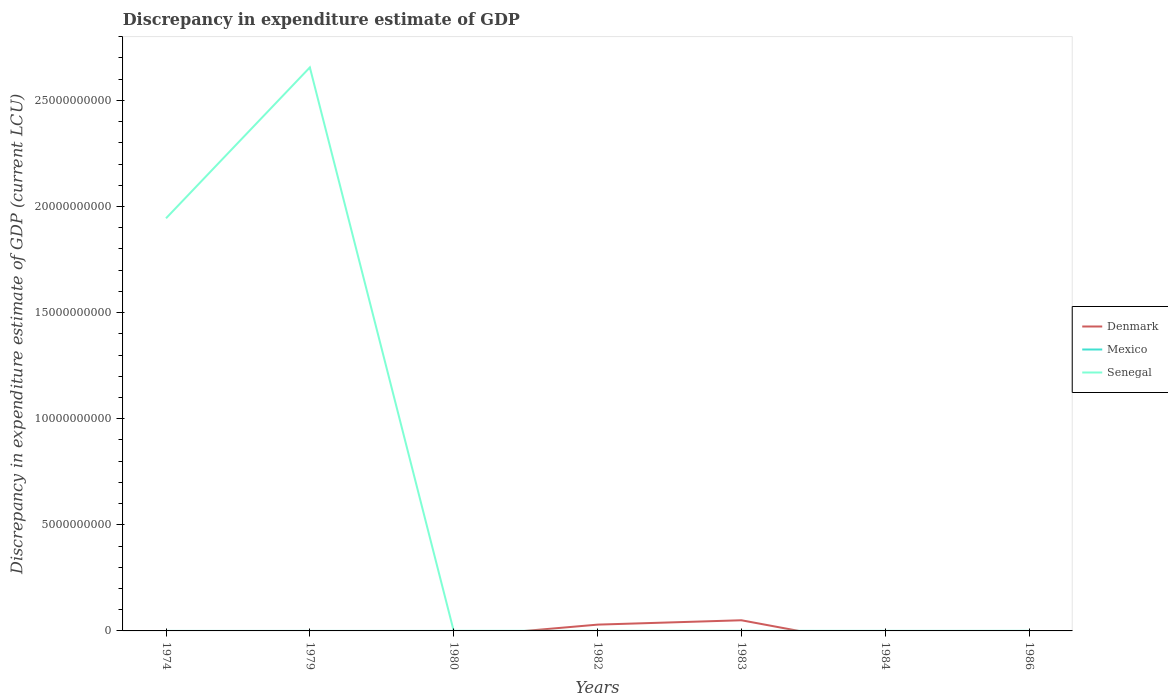How many different coloured lines are there?
Your answer should be compact. 3. Does the line corresponding to Denmark intersect with the line corresponding to Mexico?
Your answer should be very brief. Yes. What is the total discrepancy in expenditure estimate of GDP in Senegal in the graph?
Your answer should be compact. -100. What is the difference between the highest and the second highest discrepancy in expenditure estimate of GDP in Denmark?
Your answer should be very brief. 5.02e+08. Is the discrepancy in expenditure estimate of GDP in Mexico strictly greater than the discrepancy in expenditure estimate of GDP in Senegal over the years?
Keep it short and to the point. No. How many lines are there?
Your answer should be very brief. 3. What is the difference between two consecutive major ticks on the Y-axis?
Provide a succinct answer. 5.00e+09. Does the graph contain any zero values?
Offer a terse response. Yes. Does the graph contain grids?
Make the answer very short. No. How are the legend labels stacked?
Your answer should be very brief. Vertical. What is the title of the graph?
Provide a succinct answer. Discrepancy in expenditure estimate of GDP. What is the label or title of the Y-axis?
Provide a succinct answer. Discrepancy in expenditure estimate of GDP (current LCU). What is the Discrepancy in expenditure estimate of GDP (current LCU) of Denmark in 1974?
Your response must be concise. 0. What is the Discrepancy in expenditure estimate of GDP (current LCU) in Mexico in 1974?
Provide a short and direct response. 1.80e+04. What is the Discrepancy in expenditure estimate of GDP (current LCU) of Senegal in 1974?
Provide a succinct answer. 1.94e+1. What is the Discrepancy in expenditure estimate of GDP (current LCU) in Denmark in 1979?
Your response must be concise. 0. What is the Discrepancy in expenditure estimate of GDP (current LCU) in Mexico in 1979?
Provide a short and direct response. 0. What is the Discrepancy in expenditure estimate of GDP (current LCU) of Senegal in 1979?
Ensure brevity in your answer.  2.66e+1. What is the Discrepancy in expenditure estimate of GDP (current LCU) of Senegal in 1980?
Your answer should be very brief. 6e-5. What is the Discrepancy in expenditure estimate of GDP (current LCU) in Denmark in 1982?
Your answer should be compact. 2.96e+08. What is the Discrepancy in expenditure estimate of GDP (current LCU) in Senegal in 1982?
Offer a very short reply. 0. What is the Discrepancy in expenditure estimate of GDP (current LCU) in Denmark in 1983?
Give a very brief answer. 5.02e+08. What is the Discrepancy in expenditure estimate of GDP (current LCU) in Mexico in 1983?
Your response must be concise. 4.65e+05. What is the Discrepancy in expenditure estimate of GDP (current LCU) in Senegal in 1983?
Give a very brief answer. 0. What is the Discrepancy in expenditure estimate of GDP (current LCU) in Denmark in 1984?
Give a very brief answer. 0. What is the Discrepancy in expenditure estimate of GDP (current LCU) in Senegal in 1984?
Your response must be concise. 100. What is the Discrepancy in expenditure estimate of GDP (current LCU) of Mexico in 1986?
Provide a succinct answer. 9.40e+04. Across all years, what is the maximum Discrepancy in expenditure estimate of GDP (current LCU) of Denmark?
Provide a succinct answer. 5.02e+08. Across all years, what is the maximum Discrepancy in expenditure estimate of GDP (current LCU) in Mexico?
Make the answer very short. 4.65e+05. Across all years, what is the maximum Discrepancy in expenditure estimate of GDP (current LCU) in Senegal?
Make the answer very short. 2.66e+1. Across all years, what is the minimum Discrepancy in expenditure estimate of GDP (current LCU) of Denmark?
Your answer should be compact. 0. What is the total Discrepancy in expenditure estimate of GDP (current LCU) of Denmark in the graph?
Give a very brief answer. 7.99e+08. What is the total Discrepancy in expenditure estimate of GDP (current LCU) of Mexico in the graph?
Give a very brief answer. 7.07e+05. What is the total Discrepancy in expenditure estimate of GDP (current LCU) of Senegal in the graph?
Ensure brevity in your answer.  4.60e+1. What is the difference between the Discrepancy in expenditure estimate of GDP (current LCU) of Senegal in 1974 and that in 1979?
Your response must be concise. -7.11e+09. What is the difference between the Discrepancy in expenditure estimate of GDP (current LCU) in Mexico in 1974 and that in 1980?
Provide a short and direct response. -1.12e+05. What is the difference between the Discrepancy in expenditure estimate of GDP (current LCU) in Senegal in 1974 and that in 1980?
Provide a succinct answer. 1.94e+1. What is the difference between the Discrepancy in expenditure estimate of GDP (current LCU) in Senegal in 1974 and that in 1982?
Your answer should be very brief. 1.94e+1. What is the difference between the Discrepancy in expenditure estimate of GDP (current LCU) in Mexico in 1974 and that in 1983?
Your answer should be compact. -4.47e+05. What is the difference between the Discrepancy in expenditure estimate of GDP (current LCU) in Senegal in 1974 and that in 1983?
Offer a very short reply. 1.94e+1. What is the difference between the Discrepancy in expenditure estimate of GDP (current LCU) in Senegal in 1974 and that in 1984?
Your answer should be very brief. 1.94e+1. What is the difference between the Discrepancy in expenditure estimate of GDP (current LCU) in Mexico in 1974 and that in 1986?
Give a very brief answer. -7.60e+04. What is the difference between the Discrepancy in expenditure estimate of GDP (current LCU) in Senegal in 1979 and that in 1980?
Make the answer very short. 2.66e+1. What is the difference between the Discrepancy in expenditure estimate of GDP (current LCU) in Senegal in 1979 and that in 1982?
Your response must be concise. 2.66e+1. What is the difference between the Discrepancy in expenditure estimate of GDP (current LCU) of Senegal in 1979 and that in 1983?
Ensure brevity in your answer.  2.66e+1. What is the difference between the Discrepancy in expenditure estimate of GDP (current LCU) of Senegal in 1979 and that in 1984?
Your answer should be compact. 2.66e+1. What is the difference between the Discrepancy in expenditure estimate of GDP (current LCU) in Senegal in 1980 and that in 1982?
Ensure brevity in your answer.  -0. What is the difference between the Discrepancy in expenditure estimate of GDP (current LCU) in Mexico in 1980 and that in 1983?
Provide a short and direct response. -3.35e+05. What is the difference between the Discrepancy in expenditure estimate of GDP (current LCU) of Senegal in 1980 and that in 1983?
Provide a succinct answer. -0. What is the difference between the Discrepancy in expenditure estimate of GDP (current LCU) of Senegal in 1980 and that in 1984?
Make the answer very short. -100. What is the difference between the Discrepancy in expenditure estimate of GDP (current LCU) in Mexico in 1980 and that in 1986?
Offer a terse response. 3.60e+04. What is the difference between the Discrepancy in expenditure estimate of GDP (current LCU) of Denmark in 1982 and that in 1983?
Your response must be concise. -2.06e+08. What is the difference between the Discrepancy in expenditure estimate of GDP (current LCU) in Senegal in 1982 and that in 1983?
Ensure brevity in your answer.  -0. What is the difference between the Discrepancy in expenditure estimate of GDP (current LCU) of Senegal in 1982 and that in 1984?
Provide a succinct answer. -100. What is the difference between the Discrepancy in expenditure estimate of GDP (current LCU) of Senegal in 1983 and that in 1984?
Keep it short and to the point. -100. What is the difference between the Discrepancy in expenditure estimate of GDP (current LCU) of Mexico in 1983 and that in 1986?
Provide a short and direct response. 3.71e+05. What is the difference between the Discrepancy in expenditure estimate of GDP (current LCU) of Mexico in 1974 and the Discrepancy in expenditure estimate of GDP (current LCU) of Senegal in 1979?
Provide a succinct answer. -2.66e+1. What is the difference between the Discrepancy in expenditure estimate of GDP (current LCU) in Mexico in 1974 and the Discrepancy in expenditure estimate of GDP (current LCU) in Senegal in 1980?
Ensure brevity in your answer.  1.80e+04. What is the difference between the Discrepancy in expenditure estimate of GDP (current LCU) in Mexico in 1974 and the Discrepancy in expenditure estimate of GDP (current LCU) in Senegal in 1982?
Keep it short and to the point. 1.80e+04. What is the difference between the Discrepancy in expenditure estimate of GDP (current LCU) in Mexico in 1974 and the Discrepancy in expenditure estimate of GDP (current LCU) in Senegal in 1983?
Offer a terse response. 1.80e+04. What is the difference between the Discrepancy in expenditure estimate of GDP (current LCU) of Mexico in 1974 and the Discrepancy in expenditure estimate of GDP (current LCU) of Senegal in 1984?
Provide a short and direct response. 1.79e+04. What is the difference between the Discrepancy in expenditure estimate of GDP (current LCU) of Mexico in 1980 and the Discrepancy in expenditure estimate of GDP (current LCU) of Senegal in 1982?
Offer a terse response. 1.30e+05. What is the difference between the Discrepancy in expenditure estimate of GDP (current LCU) in Mexico in 1980 and the Discrepancy in expenditure estimate of GDP (current LCU) in Senegal in 1983?
Provide a short and direct response. 1.30e+05. What is the difference between the Discrepancy in expenditure estimate of GDP (current LCU) of Mexico in 1980 and the Discrepancy in expenditure estimate of GDP (current LCU) of Senegal in 1984?
Provide a short and direct response. 1.30e+05. What is the difference between the Discrepancy in expenditure estimate of GDP (current LCU) in Denmark in 1982 and the Discrepancy in expenditure estimate of GDP (current LCU) in Mexico in 1983?
Keep it short and to the point. 2.96e+08. What is the difference between the Discrepancy in expenditure estimate of GDP (current LCU) in Denmark in 1982 and the Discrepancy in expenditure estimate of GDP (current LCU) in Senegal in 1983?
Make the answer very short. 2.96e+08. What is the difference between the Discrepancy in expenditure estimate of GDP (current LCU) of Denmark in 1982 and the Discrepancy in expenditure estimate of GDP (current LCU) of Senegal in 1984?
Keep it short and to the point. 2.96e+08. What is the difference between the Discrepancy in expenditure estimate of GDP (current LCU) in Denmark in 1982 and the Discrepancy in expenditure estimate of GDP (current LCU) in Mexico in 1986?
Offer a terse response. 2.96e+08. What is the difference between the Discrepancy in expenditure estimate of GDP (current LCU) in Denmark in 1983 and the Discrepancy in expenditure estimate of GDP (current LCU) in Senegal in 1984?
Offer a terse response. 5.02e+08. What is the difference between the Discrepancy in expenditure estimate of GDP (current LCU) of Mexico in 1983 and the Discrepancy in expenditure estimate of GDP (current LCU) of Senegal in 1984?
Provide a short and direct response. 4.65e+05. What is the difference between the Discrepancy in expenditure estimate of GDP (current LCU) of Denmark in 1983 and the Discrepancy in expenditure estimate of GDP (current LCU) of Mexico in 1986?
Ensure brevity in your answer.  5.02e+08. What is the average Discrepancy in expenditure estimate of GDP (current LCU) in Denmark per year?
Ensure brevity in your answer.  1.14e+08. What is the average Discrepancy in expenditure estimate of GDP (current LCU) in Mexico per year?
Keep it short and to the point. 1.01e+05. What is the average Discrepancy in expenditure estimate of GDP (current LCU) in Senegal per year?
Provide a succinct answer. 6.57e+09. In the year 1974, what is the difference between the Discrepancy in expenditure estimate of GDP (current LCU) in Mexico and Discrepancy in expenditure estimate of GDP (current LCU) in Senegal?
Give a very brief answer. -1.94e+1. In the year 1980, what is the difference between the Discrepancy in expenditure estimate of GDP (current LCU) of Mexico and Discrepancy in expenditure estimate of GDP (current LCU) of Senegal?
Make the answer very short. 1.30e+05. In the year 1982, what is the difference between the Discrepancy in expenditure estimate of GDP (current LCU) of Denmark and Discrepancy in expenditure estimate of GDP (current LCU) of Senegal?
Provide a succinct answer. 2.96e+08. In the year 1983, what is the difference between the Discrepancy in expenditure estimate of GDP (current LCU) of Denmark and Discrepancy in expenditure estimate of GDP (current LCU) of Mexico?
Keep it short and to the point. 5.02e+08. In the year 1983, what is the difference between the Discrepancy in expenditure estimate of GDP (current LCU) of Denmark and Discrepancy in expenditure estimate of GDP (current LCU) of Senegal?
Offer a terse response. 5.02e+08. In the year 1983, what is the difference between the Discrepancy in expenditure estimate of GDP (current LCU) of Mexico and Discrepancy in expenditure estimate of GDP (current LCU) of Senegal?
Make the answer very short. 4.65e+05. What is the ratio of the Discrepancy in expenditure estimate of GDP (current LCU) in Senegal in 1974 to that in 1979?
Make the answer very short. 0.73. What is the ratio of the Discrepancy in expenditure estimate of GDP (current LCU) of Mexico in 1974 to that in 1980?
Keep it short and to the point. 0.14. What is the ratio of the Discrepancy in expenditure estimate of GDP (current LCU) of Senegal in 1974 to that in 1980?
Keep it short and to the point. 3.24e+14. What is the ratio of the Discrepancy in expenditure estimate of GDP (current LCU) in Senegal in 1974 to that in 1982?
Your response must be concise. 1.94e+14. What is the ratio of the Discrepancy in expenditure estimate of GDP (current LCU) in Mexico in 1974 to that in 1983?
Provide a succinct answer. 0.04. What is the ratio of the Discrepancy in expenditure estimate of GDP (current LCU) of Senegal in 1974 to that in 1983?
Your response must be concise. 1.30e+14. What is the ratio of the Discrepancy in expenditure estimate of GDP (current LCU) of Senegal in 1974 to that in 1984?
Make the answer very short. 1.94e+08. What is the ratio of the Discrepancy in expenditure estimate of GDP (current LCU) in Mexico in 1974 to that in 1986?
Make the answer very short. 0.19. What is the ratio of the Discrepancy in expenditure estimate of GDP (current LCU) in Senegal in 1979 to that in 1980?
Offer a very short reply. 4.43e+14. What is the ratio of the Discrepancy in expenditure estimate of GDP (current LCU) in Senegal in 1979 to that in 1982?
Give a very brief answer. 2.66e+14. What is the ratio of the Discrepancy in expenditure estimate of GDP (current LCU) in Senegal in 1979 to that in 1983?
Give a very brief answer. 1.77e+14. What is the ratio of the Discrepancy in expenditure estimate of GDP (current LCU) in Senegal in 1979 to that in 1984?
Give a very brief answer. 2.66e+08. What is the ratio of the Discrepancy in expenditure estimate of GDP (current LCU) of Mexico in 1980 to that in 1983?
Provide a succinct answer. 0.28. What is the ratio of the Discrepancy in expenditure estimate of GDP (current LCU) of Senegal in 1980 to that in 1983?
Ensure brevity in your answer.  0.4. What is the ratio of the Discrepancy in expenditure estimate of GDP (current LCU) of Senegal in 1980 to that in 1984?
Offer a very short reply. 0. What is the ratio of the Discrepancy in expenditure estimate of GDP (current LCU) of Mexico in 1980 to that in 1986?
Give a very brief answer. 1.38. What is the ratio of the Discrepancy in expenditure estimate of GDP (current LCU) of Denmark in 1982 to that in 1983?
Make the answer very short. 0.59. What is the ratio of the Discrepancy in expenditure estimate of GDP (current LCU) in Senegal in 1982 to that in 1983?
Ensure brevity in your answer.  0.67. What is the ratio of the Discrepancy in expenditure estimate of GDP (current LCU) of Mexico in 1983 to that in 1986?
Your response must be concise. 4.95. What is the difference between the highest and the second highest Discrepancy in expenditure estimate of GDP (current LCU) in Mexico?
Offer a very short reply. 3.35e+05. What is the difference between the highest and the second highest Discrepancy in expenditure estimate of GDP (current LCU) in Senegal?
Keep it short and to the point. 7.11e+09. What is the difference between the highest and the lowest Discrepancy in expenditure estimate of GDP (current LCU) of Denmark?
Your answer should be very brief. 5.02e+08. What is the difference between the highest and the lowest Discrepancy in expenditure estimate of GDP (current LCU) of Mexico?
Your answer should be very brief. 4.65e+05. What is the difference between the highest and the lowest Discrepancy in expenditure estimate of GDP (current LCU) in Senegal?
Give a very brief answer. 2.66e+1. 